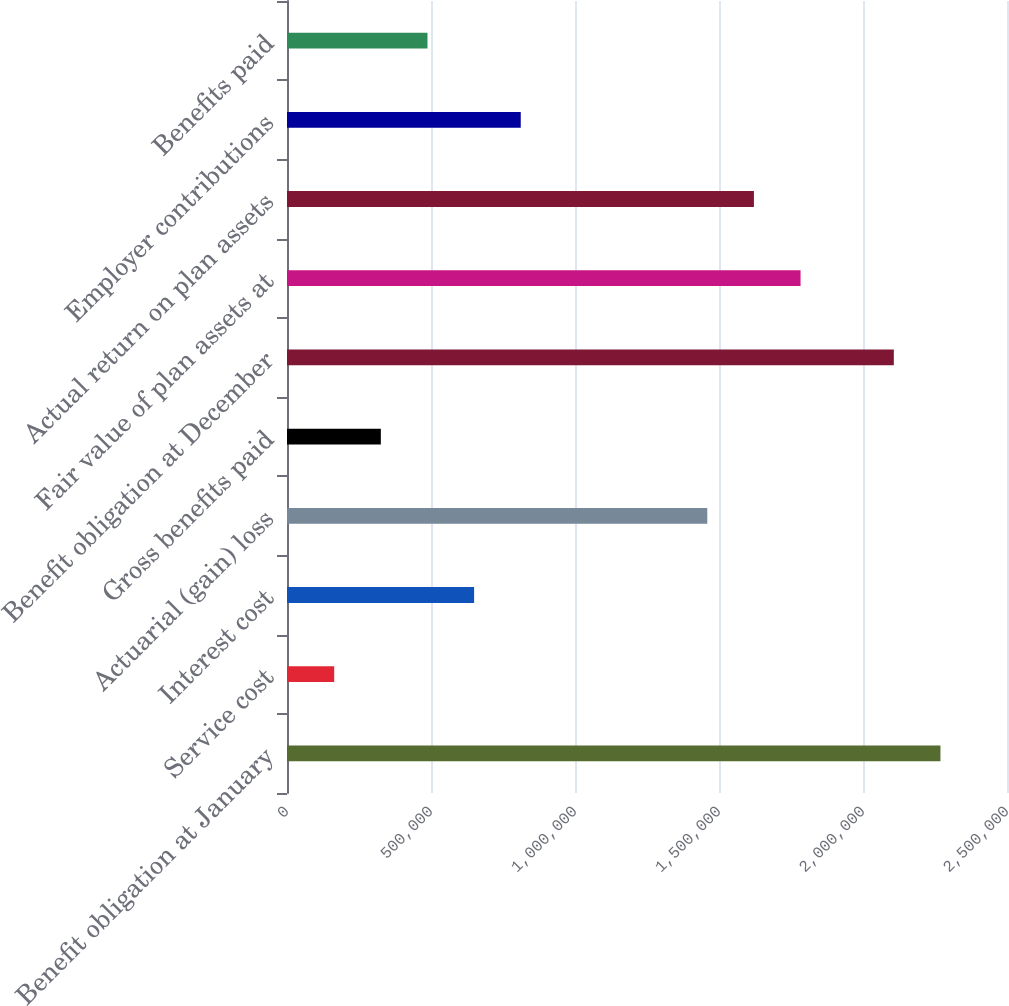Convert chart to OTSL. <chart><loc_0><loc_0><loc_500><loc_500><bar_chart><fcel>Benefit obligation at January<fcel>Service cost<fcel>Interest cost<fcel>Actuarial (gain) loss<fcel>Gross benefits paid<fcel>Benefit obligation at December<fcel>Fair value of plan assets at<fcel>Actual return on plan assets<fcel>Employer contributions<fcel>Benefits paid<nl><fcel>2.26895e+06<fcel>163896<fcel>649679<fcel>1.45932e+06<fcel>325824<fcel>2.10703e+06<fcel>1.78317e+06<fcel>1.62124e+06<fcel>811606<fcel>487752<nl></chart> 